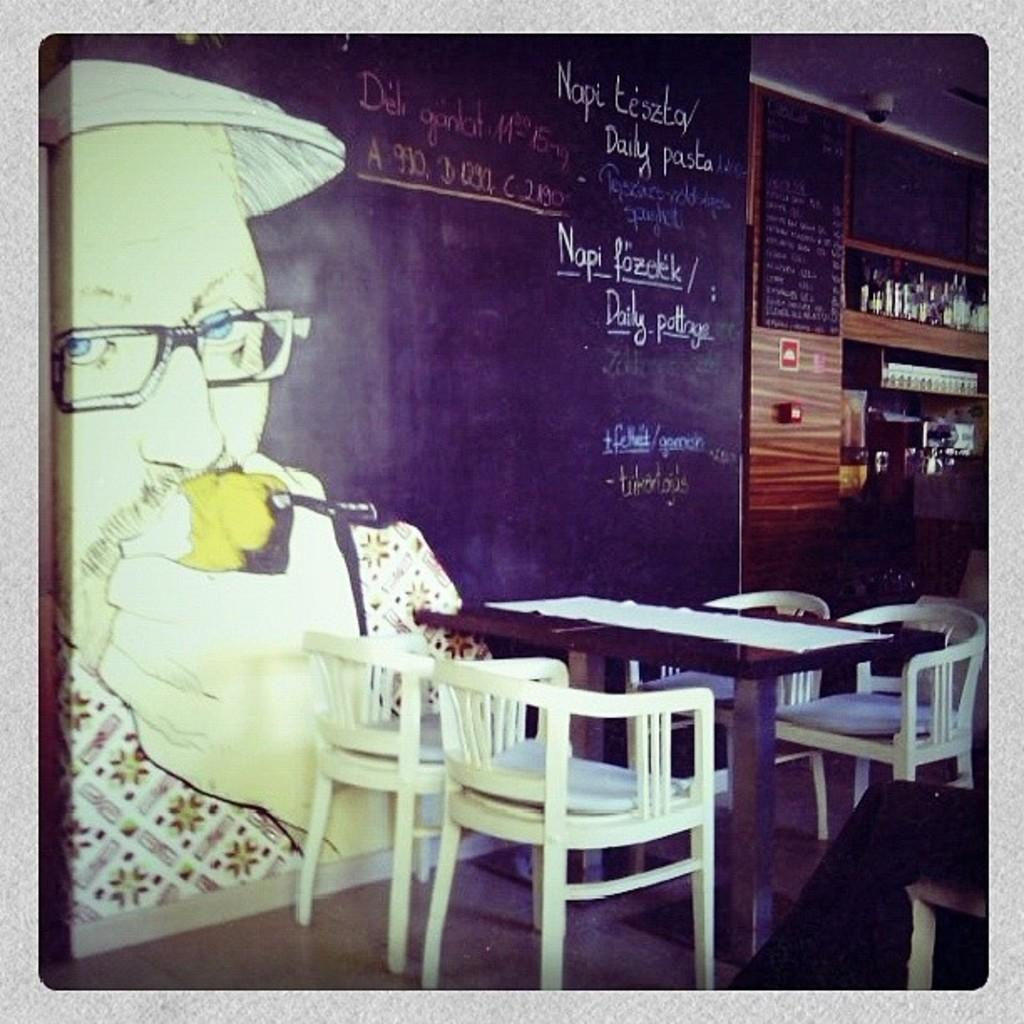What color are the chairs in the image? The chairs in the image are white. What is the main piece of furniture in the image? There is a table in the image. What is the color of the board in the image? The board in the image is black. What is depicted on the black color board? There is a painting on the black color board. How many clovers are on the table in the image? There are no clovers present in the image; the image only features chairs, a table, a black color board, and a painting. 